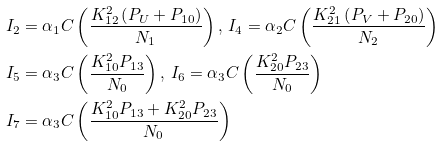<formula> <loc_0><loc_0><loc_500><loc_500>I _ { 2 } & = \alpha _ { 1 } C \left ( \frac { K _ { 1 2 } ^ { 2 } \left ( P _ { U } + P _ { 1 0 } \right ) } { N _ { 1 } } \right ) , \, I _ { 4 } = \alpha _ { 2 } C \left ( \frac { K _ { 2 1 } ^ { 2 } \left ( P _ { V } + P _ { 2 0 } \right ) } { N _ { 2 } } \right ) \\ I _ { 5 } & = \alpha _ { 3 } C \left ( \frac { K _ { 1 0 } ^ { 2 } P _ { 1 3 } } { N _ { 0 } } \right ) , \, I _ { 6 } = \alpha _ { 3 } C \left ( \frac { K _ { 2 0 } ^ { 2 } P _ { 2 3 } } { N _ { 0 } } \right ) \\ I _ { 7 } & = \alpha _ { 3 } C \left ( \frac { K _ { 1 0 } ^ { 2 } P _ { 1 3 } + K _ { 2 0 } ^ { 2 } P _ { 2 3 } } { N _ { 0 } } \right ) \,</formula> 